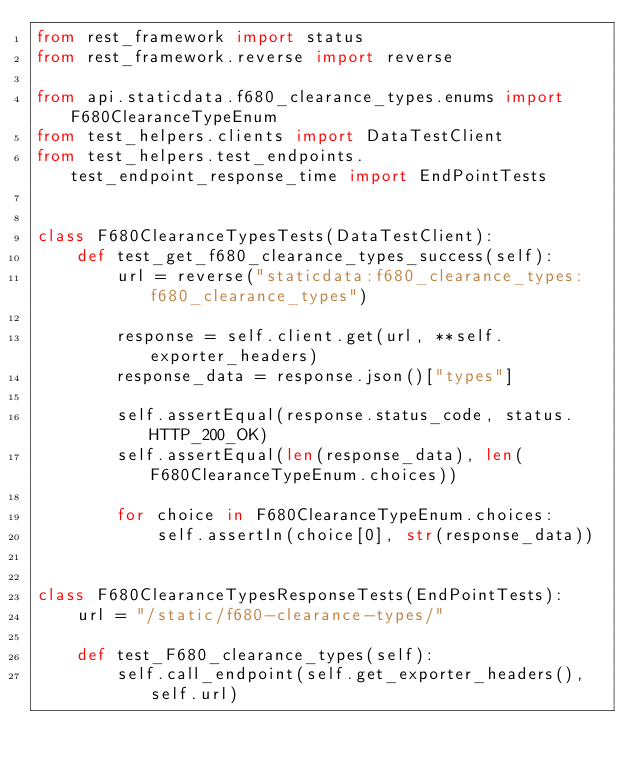Convert code to text. <code><loc_0><loc_0><loc_500><loc_500><_Python_>from rest_framework import status
from rest_framework.reverse import reverse

from api.staticdata.f680_clearance_types.enums import F680ClearanceTypeEnum
from test_helpers.clients import DataTestClient
from test_helpers.test_endpoints.test_endpoint_response_time import EndPointTests


class F680ClearanceTypesTests(DataTestClient):
    def test_get_f680_clearance_types_success(self):
        url = reverse("staticdata:f680_clearance_types:f680_clearance_types")

        response = self.client.get(url, **self.exporter_headers)
        response_data = response.json()["types"]

        self.assertEqual(response.status_code, status.HTTP_200_OK)
        self.assertEqual(len(response_data), len(F680ClearanceTypeEnum.choices))

        for choice in F680ClearanceTypeEnum.choices:
            self.assertIn(choice[0], str(response_data))


class F680ClearanceTypesResponseTests(EndPointTests):
    url = "/static/f680-clearance-types/"

    def test_F680_clearance_types(self):
        self.call_endpoint(self.get_exporter_headers(), self.url)
</code> 